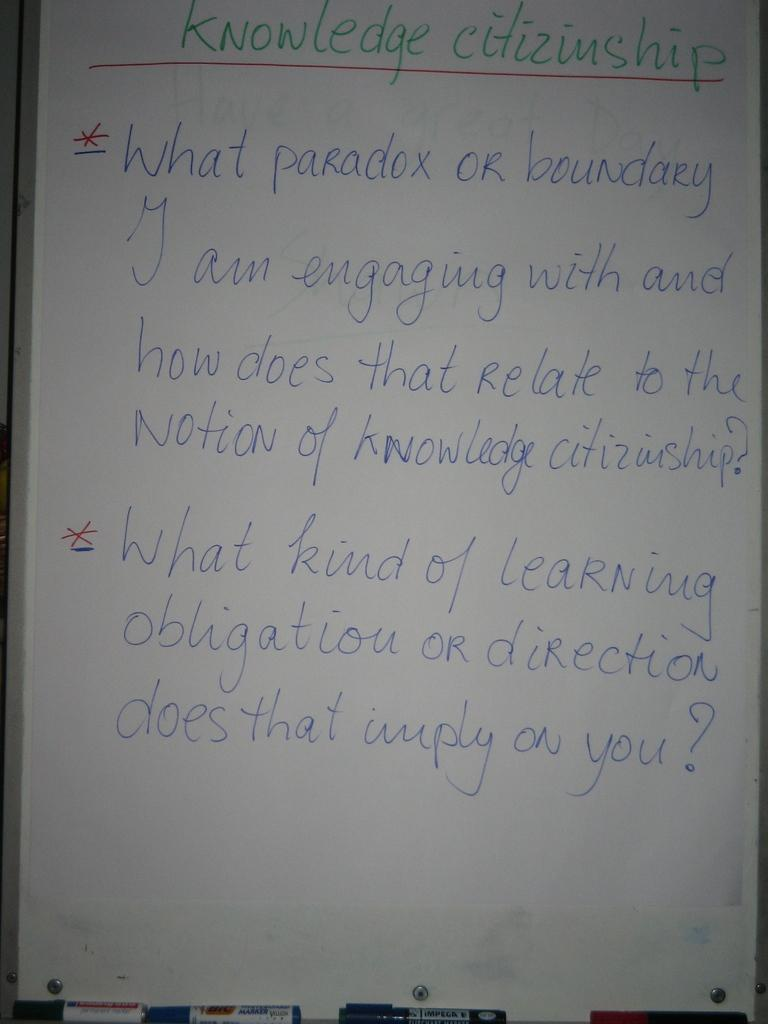<image>
Give a short and clear explanation of the subsequent image. A white board discussion on Knowledge Citizinship written in green, red, and blue markers. 